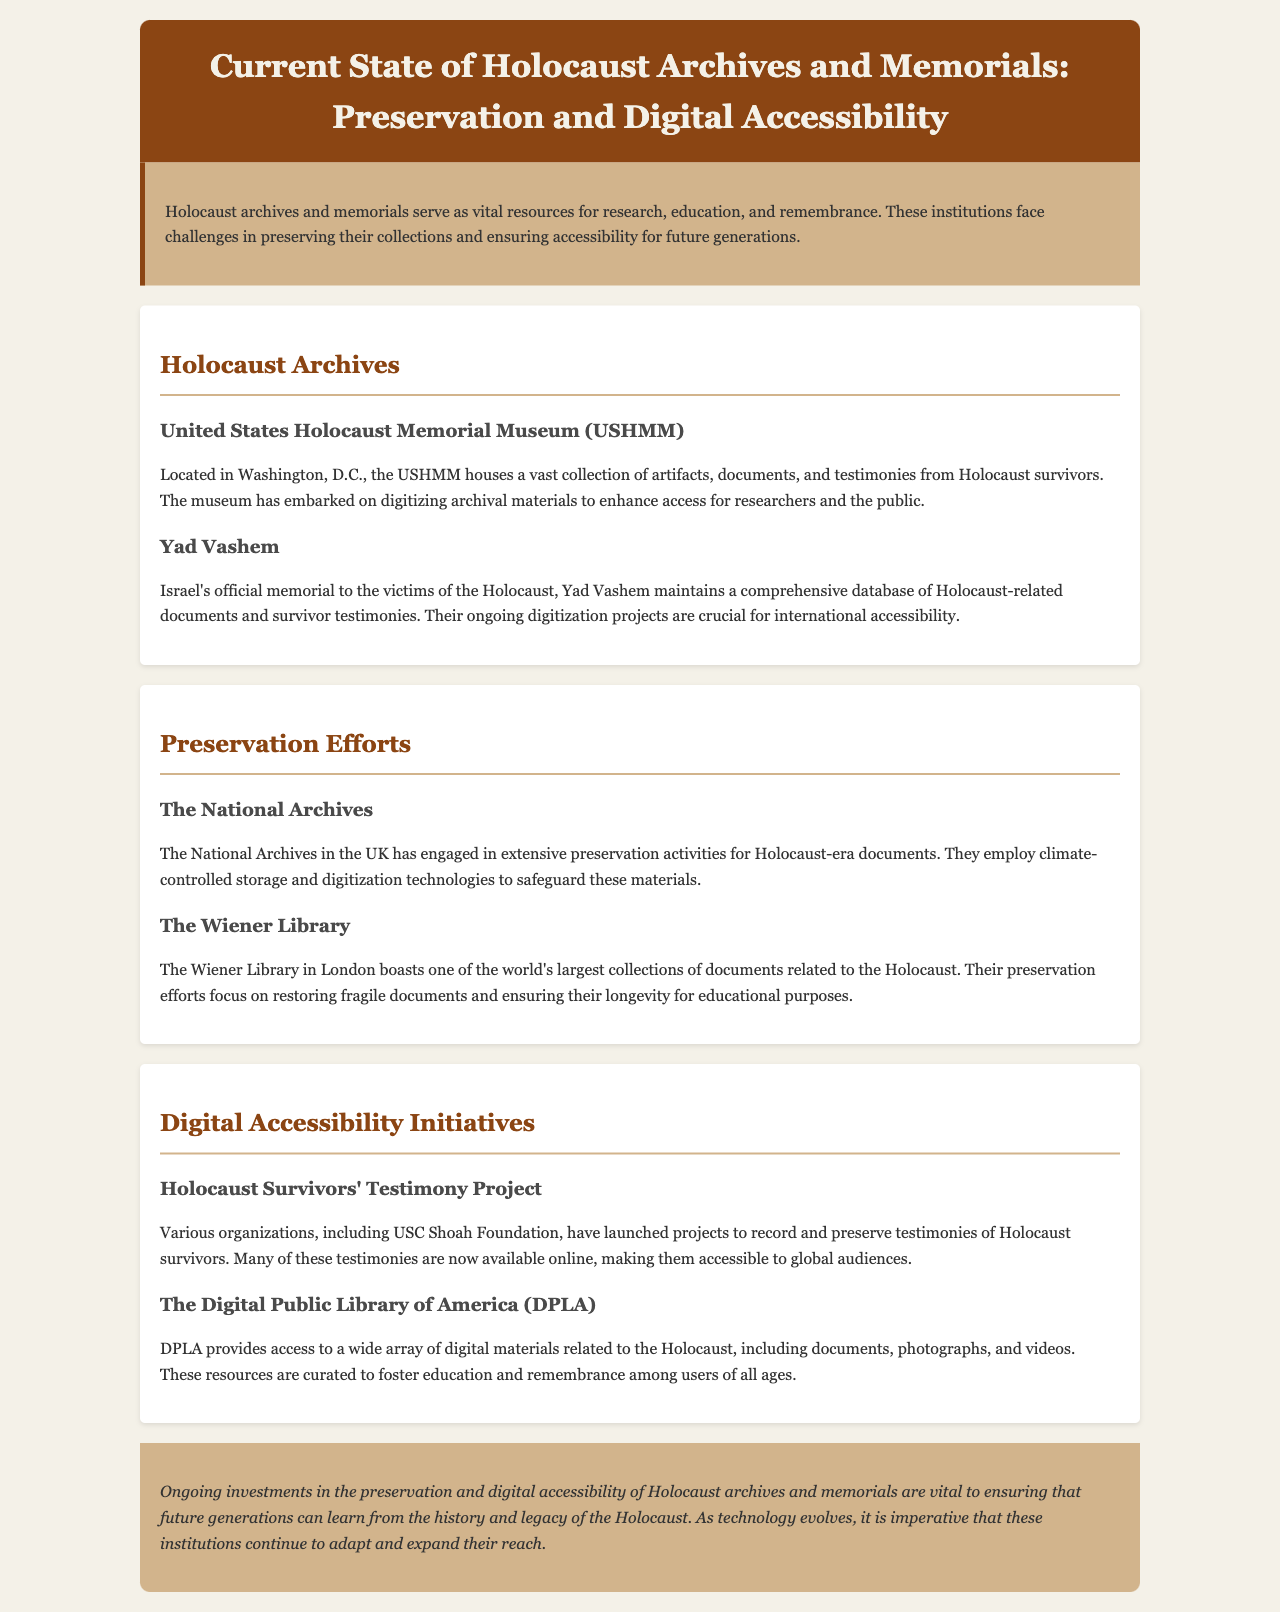What is the title of the report? The title of the report is found in the header section of the document.
Answer: Current State of Holocaust Archives and Memorials: Preservation and Digital Accessibility Where is the United States Holocaust Memorial Museum located? The location of the USHMM is stated in the section about Holocaust Archives.
Answer: Washington, D.C What major preservation technique is used by The National Archives in the UK? The preservation technique is mentioned in the section on Preservation Efforts.
Answer: Climate-controlled storage Which library boasts one of the world's largest collections of Holocaust documents? This information is found in the Preservation Efforts section.
Answer: The Wiener Library What project aims to preserve testimonies of Holocaust survivors? This project is discussed in the Digital Accessibility Initiatives section.
Answer: Holocaust Survivors' Testimony Project What type of resources does the Digital Public Library of America provide? The resources provided by DPLA are outlined in the Digital Accessibility Initiatives section.
Answer: Digital materials related to the Holocaust Why are ongoing investments important for Holocaust archives and memorials? The conclusion emphasizes the significance of investments for future generations.
Answer: Ensuring learning from history Name one organization involved in digitizing archival materials. The organizations involved are mentioned in the Holocaust Archives section.
Answer: USC Shoah Foundation 